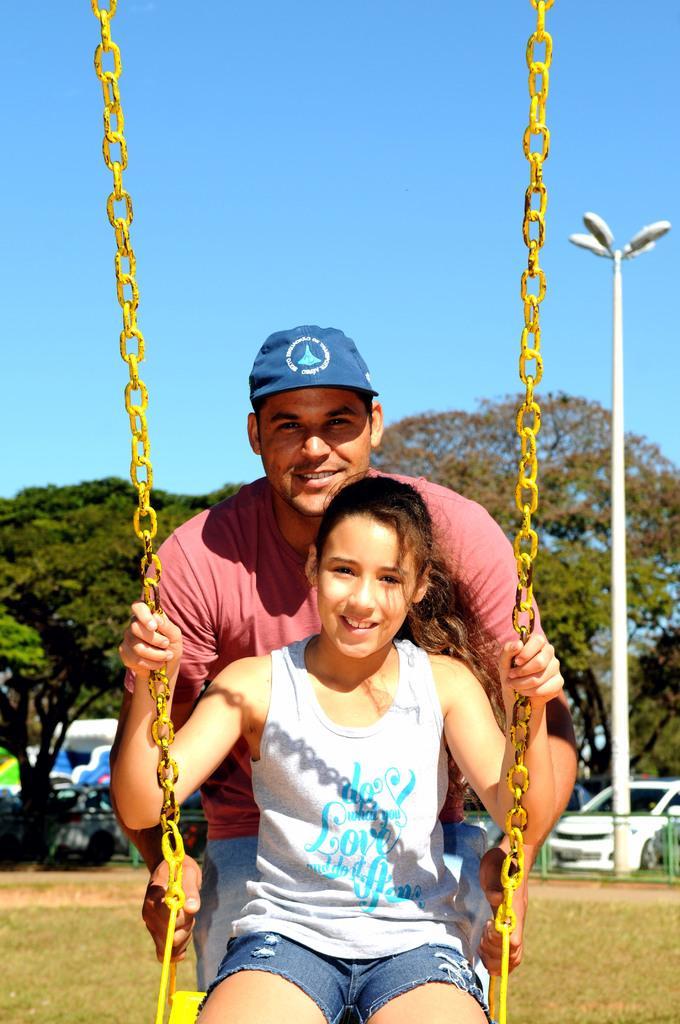How would you summarize this image in a sentence or two? In this image we can see a girl sitting on a swing. On the backside we can see a man standing holding the swing. We can also see some grass, a fence, some vehicles on the ground, a street pole, a group of trees and the sky. 